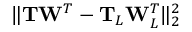Convert formula to latex. <formula><loc_0><loc_0><loc_500><loc_500>\| T W ^ { T } - T _ { L } W _ { L } ^ { T } \| _ { 2 } ^ { 2 }</formula> 